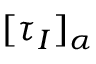Convert formula to latex. <formula><loc_0><loc_0><loc_500><loc_500>[ \tau _ { I } ] _ { \alpha }</formula> 